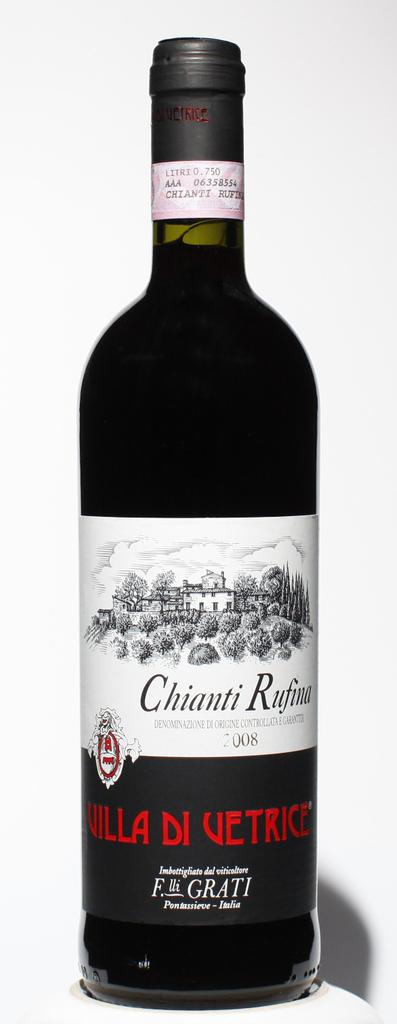Provide a one-sentence caption for the provided image. Wine that has Chianti written on the front. 